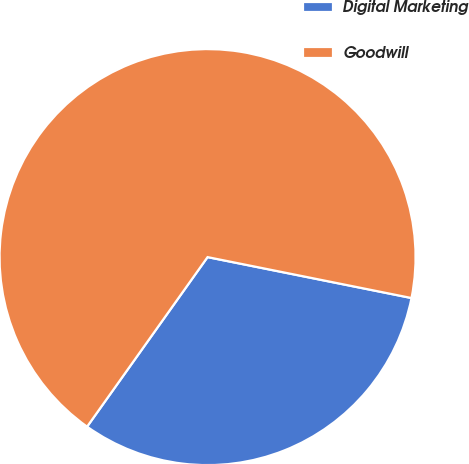<chart> <loc_0><loc_0><loc_500><loc_500><pie_chart><fcel>Digital Marketing<fcel>Goodwill<nl><fcel>31.68%<fcel>68.32%<nl></chart> 